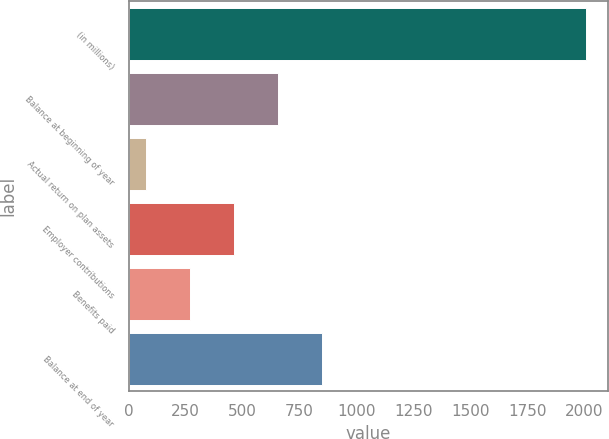Convert chart. <chart><loc_0><loc_0><loc_500><loc_500><bar_chart><fcel>(in millions)<fcel>Balance at beginning of year<fcel>Actual return on plan assets<fcel>Employer contributions<fcel>Benefits paid<fcel>Balance at end of year<nl><fcel>2005<fcel>656.1<fcel>78<fcel>463.4<fcel>270.7<fcel>848.8<nl></chart> 